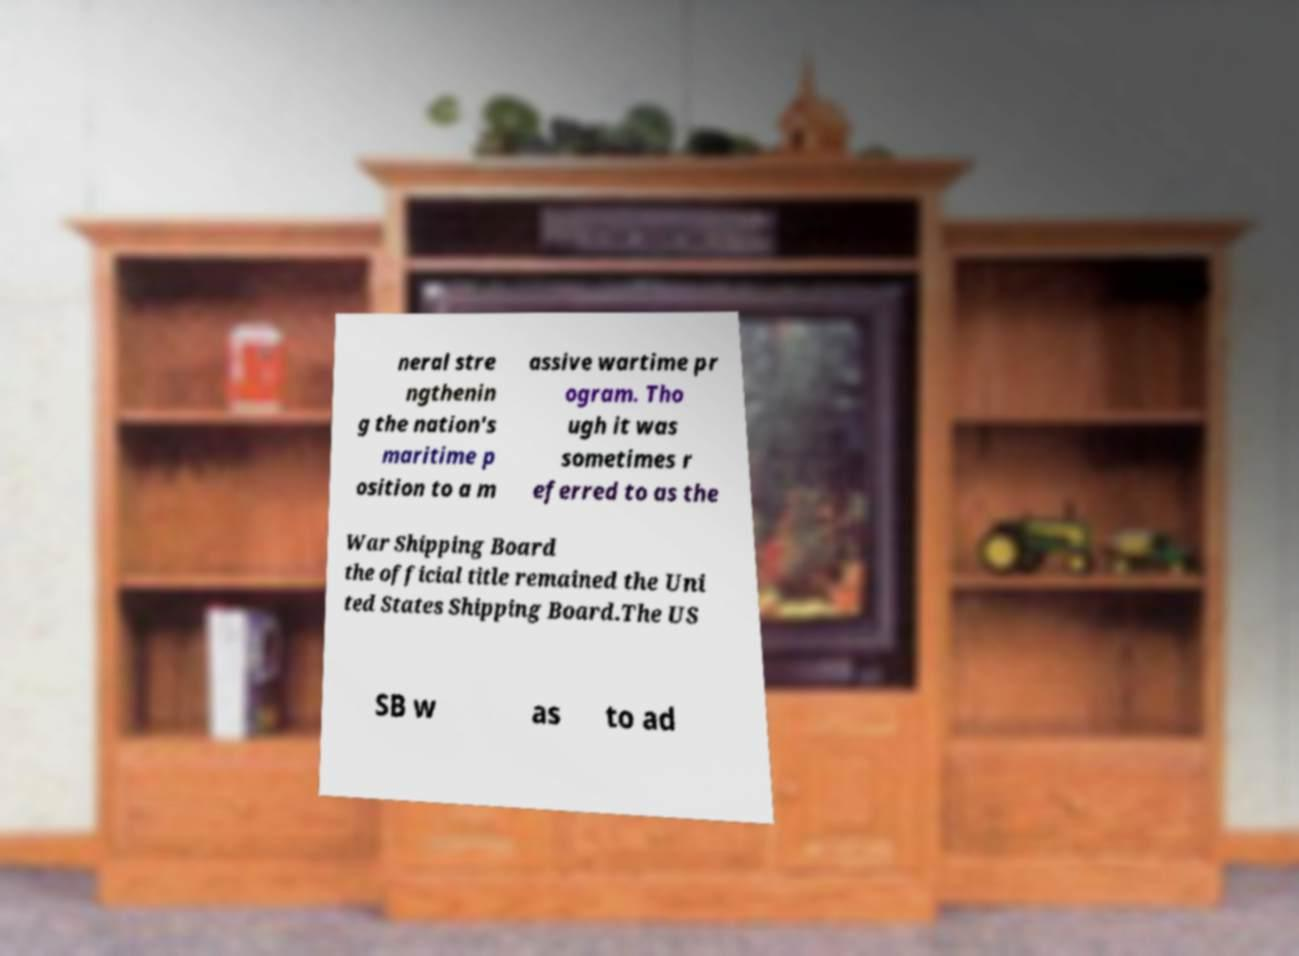What messages or text are displayed in this image? I need them in a readable, typed format. neral stre ngthenin g the nation's maritime p osition to a m assive wartime pr ogram. Tho ugh it was sometimes r eferred to as the War Shipping Board the official title remained the Uni ted States Shipping Board.The US SB w as to ad 